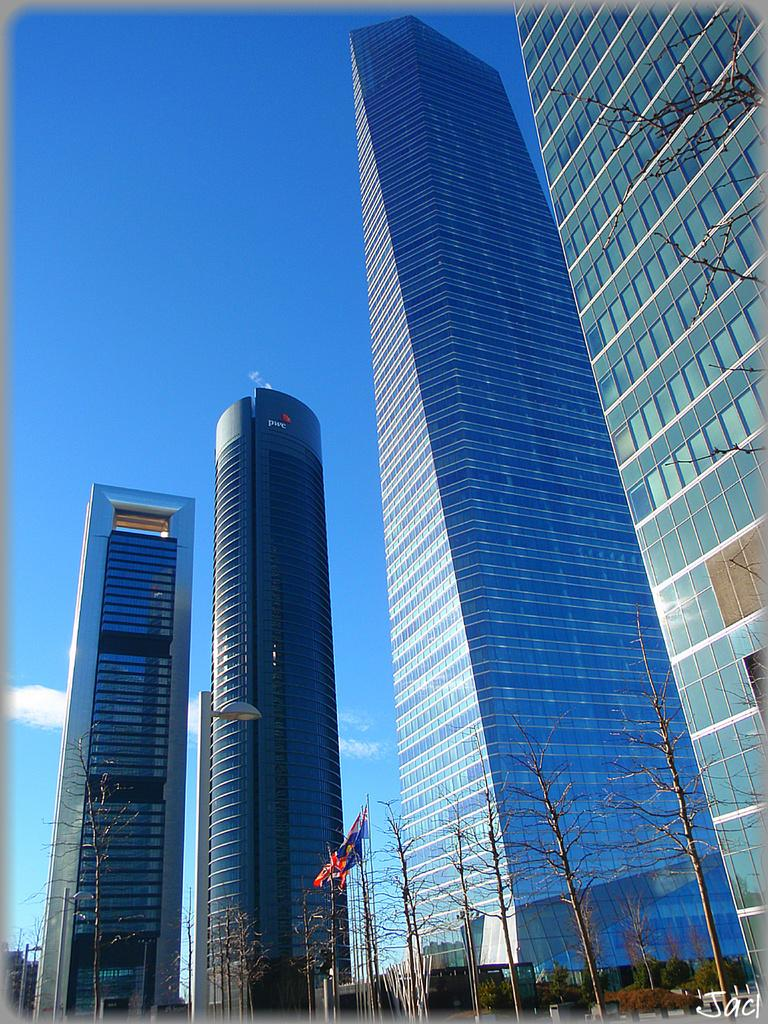What type of structures can be seen in the image? There are many buildings in the image. What other elements are present in the image besides buildings? There are trees and a flag visible in the image. What can be seen in the background of the image? The sky with clouds is visible in the background of the image. Is there any additional mark or feature in the image? Yes, there is a watermark in the right bottom corner of the image. How many planes can be seen flying over the buildings in the image? There are no planes visible in the image; it only features buildings, trees, a flag, and the sky with clouds in the background. What type of collar is on the trees in the image? There are no collars present on the trees in the image; they are natural trees with no additional accessories. 